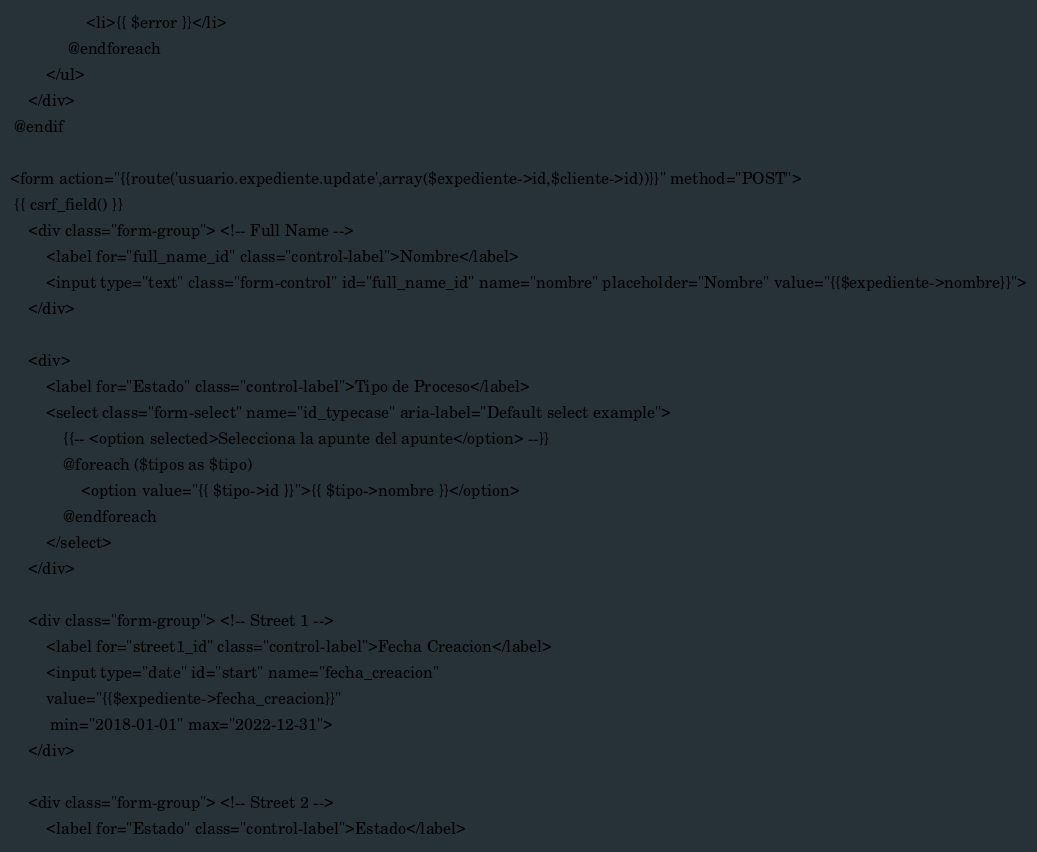Convert code to text. <code><loc_0><loc_0><loc_500><loc_500><_PHP_>                 <li>{{ $error }}</li>
             @endforeach
        </ul>
    </div>
 @endif

<form action="{{route('usuario.expediente.update',array($expediente->id,$cliente->id))}}" method="POST">
 {{ csrf_field() }}
    <div class="form-group"> <!-- Full Name -->
        <label for="full_name_id" class="control-label">Nombre</label>
        <input type="text" class="form-control" id="full_name_id" name="nombre" placeholder="Nombre" value="{{$expediente->nombre}}">
    </div>    

    <div>
        <label for="Estado" class="control-label">Tipo de Proceso</label>
        <select class="form-select" name="id_typecase" aria-label="Default select example">
            {{-- <option selected>Selecciona la apunte del apunte</option> --}}
            @foreach ($tipos as $tipo)
                <option value="{{ $tipo->id }}">{{ $tipo->nombre }}</option>
            @endforeach
        </select>
    </div>

    <div class="form-group"> <!-- Street 1 -->
        <label for="street1_id" class="control-label">Fecha Creacion</label>
        <input type="date" id="start" name="fecha_creacion"
        value="{{$expediente->fecha_creacion}}"
         min="2018-01-01" max="2022-12-31">
    </div>                    
                            
    <div class="form-group"> <!-- Street 2 -->
        <label for="Estado" class="control-label">Estado</label></code> 